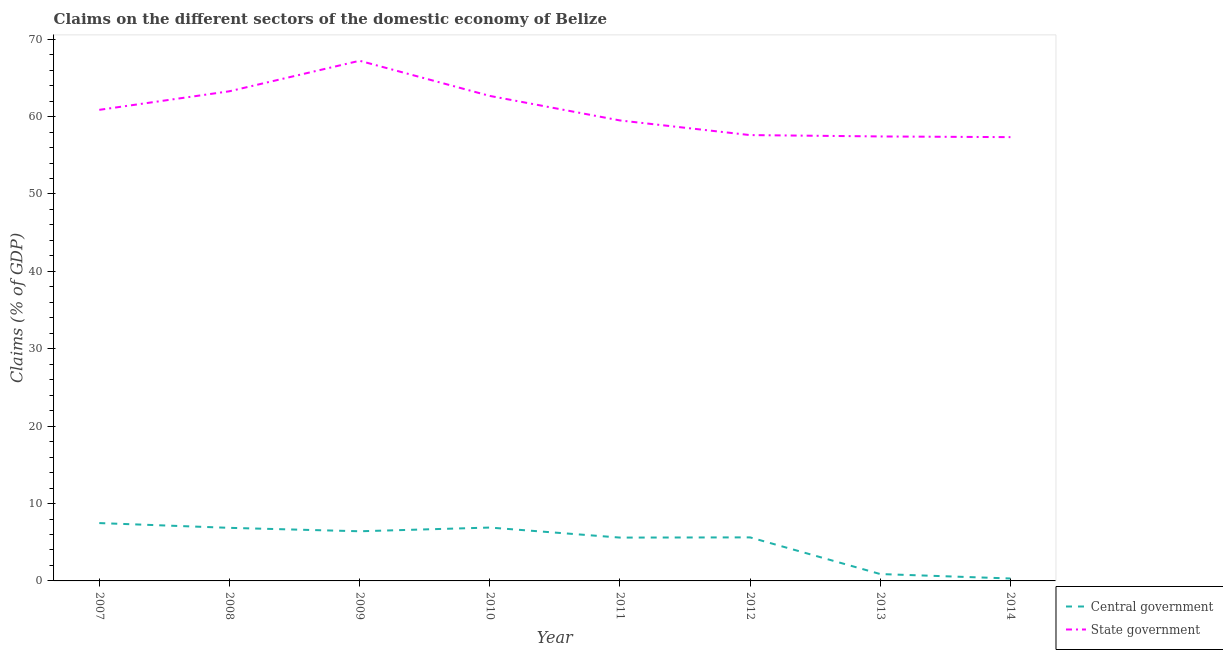How many different coloured lines are there?
Offer a terse response. 2. What is the claims on state government in 2007?
Your answer should be very brief. 60.87. Across all years, what is the maximum claims on central government?
Provide a short and direct response. 7.47. Across all years, what is the minimum claims on state government?
Keep it short and to the point. 57.35. In which year was the claims on state government maximum?
Ensure brevity in your answer.  2009. What is the total claims on state government in the graph?
Make the answer very short. 485.93. What is the difference between the claims on central government in 2008 and that in 2010?
Ensure brevity in your answer.  -0.04. What is the difference between the claims on central government in 2011 and the claims on state government in 2013?
Your answer should be very brief. -51.84. What is the average claims on central government per year?
Your response must be concise. 5.01. In the year 2011, what is the difference between the claims on state government and claims on central government?
Offer a very short reply. 53.9. What is the ratio of the claims on state government in 2011 to that in 2013?
Your answer should be compact. 1.04. Is the claims on central government in 2009 less than that in 2014?
Offer a very short reply. No. Is the difference between the claims on central government in 2007 and 2012 greater than the difference between the claims on state government in 2007 and 2012?
Keep it short and to the point. No. What is the difference between the highest and the second highest claims on state government?
Your answer should be very brief. 3.94. What is the difference between the highest and the lowest claims on state government?
Offer a very short reply. 9.87. In how many years, is the claims on state government greater than the average claims on state government taken over all years?
Provide a succinct answer. 4. How many lines are there?
Offer a very short reply. 2. How many years are there in the graph?
Offer a terse response. 8. Are the values on the major ticks of Y-axis written in scientific E-notation?
Your response must be concise. No. Does the graph contain any zero values?
Give a very brief answer. No. Where does the legend appear in the graph?
Ensure brevity in your answer.  Bottom right. What is the title of the graph?
Your response must be concise. Claims on the different sectors of the domestic economy of Belize. Does "Forest" appear as one of the legend labels in the graph?
Your response must be concise. No. What is the label or title of the X-axis?
Offer a terse response. Year. What is the label or title of the Y-axis?
Your answer should be very brief. Claims (% of GDP). What is the Claims (% of GDP) of Central government in 2007?
Provide a short and direct response. 7.47. What is the Claims (% of GDP) of State government in 2007?
Your response must be concise. 60.87. What is the Claims (% of GDP) of Central government in 2008?
Provide a short and direct response. 6.86. What is the Claims (% of GDP) in State government in 2008?
Make the answer very short. 63.27. What is the Claims (% of GDP) of Central government in 2009?
Offer a terse response. 6.42. What is the Claims (% of GDP) in State government in 2009?
Provide a short and direct response. 67.22. What is the Claims (% of GDP) in Central government in 2010?
Your response must be concise. 6.9. What is the Claims (% of GDP) of State government in 2010?
Offer a terse response. 62.67. What is the Claims (% of GDP) in Central government in 2011?
Your answer should be very brief. 5.6. What is the Claims (% of GDP) of State government in 2011?
Ensure brevity in your answer.  59.5. What is the Claims (% of GDP) in Central government in 2012?
Provide a succinct answer. 5.63. What is the Claims (% of GDP) of State government in 2012?
Give a very brief answer. 57.61. What is the Claims (% of GDP) in Central government in 2013?
Give a very brief answer. 0.89. What is the Claims (% of GDP) of State government in 2013?
Provide a succinct answer. 57.44. What is the Claims (% of GDP) in Central government in 2014?
Your response must be concise. 0.32. What is the Claims (% of GDP) in State government in 2014?
Provide a short and direct response. 57.35. Across all years, what is the maximum Claims (% of GDP) of Central government?
Your answer should be compact. 7.47. Across all years, what is the maximum Claims (% of GDP) of State government?
Give a very brief answer. 67.22. Across all years, what is the minimum Claims (% of GDP) of Central government?
Your answer should be compact. 0.32. Across all years, what is the minimum Claims (% of GDP) of State government?
Offer a terse response. 57.35. What is the total Claims (% of GDP) of Central government in the graph?
Your answer should be very brief. 40.07. What is the total Claims (% of GDP) in State government in the graph?
Make the answer very short. 485.93. What is the difference between the Claims (% of GDP) of Central government in 2007 and that in 2008?
Keep it short and to the point. 0.62. What is the difference between the Claims (% of GDP) of State government in 2007 and that in 2008?
Ensure brevity in your answer.  -2.4. What is the difference between the Claims (% of GDP) in Central government in 2007 and that in 2009?
Your response must be concise. 1.06. What is the difference between the Claims (% of GDP) in State government in 2007 and that in 2009?
Provide a succinct answer. -6.34. What is the difference between the Claims (% of GDP) of Central government in 2007 and that in 2010?
Offer a terse response. 0.58. What is the difference between the Claims (% of GDP) in State government in 2007 and that in 2010?
Your response must be concise. -1.8. What is the difference between the Claims (% of GDP) of Central government in 2007 and that in 2011?
Provide a short and direct response. 1.88. What is the difference between the Claims (% of GDP) in State government in 2007 and that in 2011?
Offer a very short reply. 1.37. What is the difference between the Claims (% of GDP) in Central government in 2007 and that in 2012?
Give a very brief answer. 1.85. What is the difference between the Claims (% of GDP) of State government in 2007 and that in 2012?
Keep it short and to the point. 3.26. What is the difference between the Claims (% of GDP) in Central government in 2007 and that in 2013?
Your response must be concise. 6.59. What is the difference between the Claims (% of GDP) of State government in 2007 and that in 2013?
Ensure brevity in your answer.  3.44. What is the difference between the Claims (% of GDP) of Central government in 2007 and that in 2014?
Your answer should be compact. 7.16. What is the difference between the Claims (% of GDP) of State government in 2007 and that in 2014?
Provide a short and direct response. 3.53. What is the difference between the Claims (% of GDP) in Central government in 2008 and that in 2009?
Offer a very short reply. 0.44. What is the difference between the Claims (% of GDP) of State government in 2008 and that in 2009?
Your answer should be very brief. -3.94. What is the difference between the Claims (% of GDP) of Central government in 2008 and that in 2010?
Make the answer very short. -0.04. What is the difference between the Claims (% of GDP) in State government in 2008 and that in 2010?
Your answer should be very brief. 0.6. What is the difference between the Claims (% of GDP) of Central government in 2008 and that in 2011?
Your answer should be very brief. 1.26. What is the difference between the Claims (% of GDP) of State government in 2008 and that in 2011?
Provide a short and direct response. 3.77. What is the difference between the Claims (% of GDP) in Central government in 2008 and that in 2012?
Keep it short and to the point. 1.23. What is the difference between the Claims (% of GDP) in State government in 2008 and that in 2012?
Offer a terse response. 5.66. What is the difference between the Claims (% of GDP) in Central government in 2008 and that in 2013?
Offer a terse response. 5.97. What is the difference between the Claims (% of GDP) of State government in 2008 and that in 2013?
Your response must be concise. 5.84. What is the difference between the Claims (% of GDP) in Central government in 2008 and that in 2014?
Keep it short and to the point. 6.54. What is the difference between the Claims (% of GDP) in State government in 2008 and that in 2014?
Your response must be concise. 5.93. What is the difference between the Claims (% of GDP) in Central government in 2009 and that in 2010?
Ensure brevity in your answer.  -0.48. What is the difference between the Claims (% of GDP) of State government in 2009 and that in 2010?
Provide a succinct answer. 4.54. What is the difference between the Claims (% of GDP) in Central government in 2009 and that in 2011?
Give a very brief answer. 0.82. What is the difference between the Claims (% of GDP) in State government in 2009 and that in 2011?
Provide a succinct answer. 7.71. What is the difference between the Claims (% of GDP) of Central government in 2009 and that in 2012?
Provide a succinct answer. 0.79. What is the difference between the Claims (% of GDP) of State government in 2009 and that in 2012?
Offer a very short reply. 9.6. What is the difference between the Claims (% of GDP) in Central government in 2009 and that in 2013?
Ensure brevity in your answer.  5.53. What is the difference between the Claims (% of GDP) in State government in 2009 and that in 2013?
Offer a terse response. 9.78. What is the difference between the Claims (% of GDP) in Central government in 2009 and that in 2014?
Give a very brief answer. 6.1. What is the difference between the Claims (% of GDP) in State government in 2009 and that in 2014?
Provide a short and direct response. 9.87. What is the difference between the Claims (% of GDP) of Central government in 2010 and that in 2011?
Make the answer very short. 1.3. What is the difference between the Claims (% of GDP) in State government in 2010 and that in 2011?
Your answer should be very brief. 3.17. What is the difference between the Claims (% of GDP) in Central government in 2010 and that in 2012?
Give a very brief answer. 1.27. What is the difference between the Claims (% of GDP) of State government in 2010 and that in 2012?
Your answer should be very brief. 5.06. What is the difference between the Claims (% of GDP) of Central government in 2010 and that in 2013?
Your answer should be compact. 6.01. What is the difference between the Claims (% of GDP) of State government in 2010 and that in 2013?
Your response must be concise. 5.24. What is the difference between the Claims (% of GDP) of Central government in 2010 and that in 2014?
Your response must be concise. 6.58. What is the difference between the Claims (% of GDP) of State government in 2010 and that in 2014?
Make the answer very short. 5.33. What is the difference between the Claims (% of GDP) of Central government in 2011 and that in 2012?
Provide a succinct answer. -0.03. What is the difference between the Claims (% of GDP) of State government in 2011 and that in 2012?
Make the answer very short. 1.89. What is the difference between the Claims (% of GDP) of Central government in 2011 and that in 2013?
Your response must be concise. 4.71. What is the difference between the Claims (% of GDP) in State government in 2011 and that in 2013?
Ensure brevity in your answer.  2.07. What is the difference between the Claims (% of GDP) of Central government in 2011 and that in 2014?
Your answer should be compact. 5.28. What is the difference between the Claims (% of GDP) of State government in 2011 and that in 2014?
Ensure brevity in your answer.  2.16. What is the difference between the Claims (% of GDP) in Central government in 2012 and that in 2013?
Make the answer very short. 4.74. What is the difference between the Claims (% of GDP) in State government in 2012 and that in 2013?
Provide a short and direct response. 0.18. What is the difference between the Claims (% of GDP) in Central government in 2012 and that in 2014?
Your answer should be very brief. 5.31. What is the difference between the Claims (% of GDP) of State government in 2012 and that in 2014?
Offer a very short reply. 0.27. What is the difference between the Claims (% of GDP) in Central government in 2013 and that in 2014?
Make the answer very short. 0.57. What is the difference between the Claims (% of GDP) in State government in 2013 and that in 2014?
Provide a short and direct response. 0.09. What is the difference between the Claims (% of GDP) of Central government in 2007 and the Claims (% of GDP) of State government in 2008?
Offer a very short reply. -55.8. What is the difference between the Claims (% of GDP) of Central government in 2007 and the Claims (% of GDP) of State government in 2009?
Give a very brief answer. -59.74. What is the difference between the Claims (% of GDP) of Central government in 2007 and the Claims (% of GDP) of State government in 2010?
Make the answer very short. -55.2. What is the difference between the Claims (% of GDP) of Central government in 2007 and the Claims (% of GDP) of State government in 2011?
Your response must be concise. -52.03. What is the difference between the Claims (% of GDP) in Central government in 2007 and the Claims (% of GDP) in State government in 2012?
Keep it short and to the point. -50.14. What is the difference between the Claims (% of GDP) of Central government in 2007 and the Claims (% of GDP) of State government in 2013?
Your answer should be compact. -49.96. What is the difference between the Claims (% of GDP) in Central government in 2007 and the Claims (% of GDP) in State government in 2014?
Provide a short and direct response. -49.87. What is the difference between the Claims (% of GDP) of Central government in 2008 and the Claims (% of GDP) of State government in 2009?
Your answer should be very brief. -60.36. What is the difference between the Claims (% of GDP) in Central government in 2008 and the Claims (% of GDP) in State government in 2010?
Offer a terse response. -55.82. What is the difference between the Claims (% of GDP) of Central government in 2008 and the Claims (% of GDP) of State government in 2011?
Make the answer very short. -52.65. What is the difference between the Claims (% of GDP) in Central government in 2008 and the Claims (% of GDP) in State government in 2012?
Your answer should be very brief. -50.75. What is the difference between the Claims (% of GDP) in Central government in 2008 and the Claims (% of GDP) in State government in 2013?
Ensure brevity in your answer.  -50.58. What is the difference between the Claims (% of GDP) in Central government in 2008 and the Claims (% of GDP) in State government in 2014?
Give a very brief answer. -50.49. What is the difference between the Claims (% of GDP) of Central government in 2009 and the Claims (% of GDP) of State government in 2010?
Give a very brief answer. -56.26. What is the difference between the Claims (% of GDP) of Central government in 2009 and the Claims (% of GDP) of State government in 2011?
Make the answer very short. -53.09. What is the difference between the Claims (% of GDP) in Central government in 2009 and the Claims (% of GDP) in State government in 2012?
Ensure brevity in your answer.  -51.2. What is the difference between the Claims (% of GDP) of Central government in 2009 and the Claims (% of GDP) of State government in 2013?
Offer a very short reply. -51.02. What is the difference between the Claims (% of GDP) of Central government in 2009 and the Claims (% of GDP) of State government in 2014?
Keep it short and to the point. -50.93. What is the difference between the Claims (% of GDP) of Central government in 2010 and the Claims (% of GDP) of State government in 2011?
Keep it short and to the point. -52.61. What is the difference between the Claims (% of GDP) of Central government in 2010 and the Claims (% of GDP) of State government in 2012?
Your answer should be very brief. -50.72. What is the difference between the Claims (% of GDP) of Central government in 2010 and the Claims (% of GDP) of State government in 2013?
Keep it short and to the point. -50.54. What is the difference between the Claims (% of GDP) of Central government in 2010 and the Claims (% of GDP) of State government in 2014?
Give a very brief answer. -50.45. What is the difference between the Claims (% of GDP) of Central government in 2011 and the Claims (% of GDP) of State government in 2012?
Provide a succinct answer. -52.01. What is the difference between the Claims (% of GDP) of Central government in 2011 and the Claims (% of GDP) of State government in 2013?
Your answer should be compact. -51.84. What is the difference between the Claims (% of GDP) of Central government in 2011 and the Claims (% of GDP) of State government in 2014?
Offer a very short reply. -51.75. What is the difference between the Claims (% of GDP) in Central government in 2012 and the Claims (% of GDP) in State government in 2013?
Your answer should be very brief. -51.81. What is the difference between the Claims (% of GDP) in Central government in 2012 and the Claims (% of GDP) in State government in 2014?
Your response must be concise. -51.72. What is the difference between the Claims (% of GDP) in Central government in 2013 and the Claims (% of GDP) in State government in 2014?
Keep it short and to the point. -56.46. What is the average Claims (% of GDP) of Central government per year?
Your answer should be compact. 5.01. What is the average Claims (% of GDP) of State government per year?
Provide a short and direct response. 60.74. In the year 2007, what is the difference between the Claims (% of GDP) in Central government and Claims (% of GDP) in State government?
Your answer should be compact. -53.4. In the year 2008, what is the difference between the Claims (% of GDP) in Central government and Claims (% of GDP) in State government?
Offer a very short reply. -56.42. In the year 2009, what is the difference between the Claims (% of GDP) in Central government and Claims (% of GDP) in State government?
Your answer should be very brief. -60.8. In the year 2010, what is the difference between the Claims (% of GDP) in Central government and Claims (% of GDP) in State government?
Keep it short and to the point. -55.78. In the year 2011, what is the difference between the Claims (% of GDP) of Central government and Claims (% of GDP) of State government?
Ensure brevity in your answer.  -53.9. In the year 2012, what is the difference between the Claims (% of GDP) of Central government and Claims (% of GDP) of State government?
Ensure brevity in your answer.  -51.99. In the year 2013, what is the difference between the Claims (% of GDP) of Central government and Claims (% of GDP) of State government?
Keep it short and to the point. -56.55. In the year 2014, what is the difference between the Claims (% of GDP) in Central government and Claims (% of GDP) in State government?
Provide a succinct answer. -57.03. What is the ratio of the Claims (% of GDP) of Central government in 2007 to that in 2008?
Your answer should be very brief. 1.09. What is the ratio of the Claims (% of GDP) in State government in 2007 to that in 2008?
Provide a succinct answer. 0.96. What is the ratio of the Claims (% of GDP) in Central government in 2007 to that in 2009?
Give a very brief answer. 1.17. What is the ratio of the Claims (% of GDP) in State government in 2007 to that in 2009?
Your answer should be very brief. 0.91. What is the ratio of the Claims (% of GDP) in Central government in 2007 to that in 2010?
Provide a succinct answer. 1.08. What is the ratio of the Claims (% of GDP) of State government in 2007 to that in 2010?
Ensure brevity in your answer.  0.97. What is the ratio of the Claims (% of GDP) in Central government in 2007 to that in 2011?
Your response must be concise. 1.33. What is the ratio of the Claims (% of GDP) of Central government in 2007 to that in 2012?
Provide a succinct answer. 1.33. What is the ratio of the Claims (% of GDP) in State government in 2007 to that in 2012?
Provide a short and direct response. 1.06. What is the ratio of the Claims (% of GDP) in Central government in 2007 to that in 2013?
Offer a terse response. 8.42. What is the ratio of the Claims (% of GDP) in State government in 2007 to that in 2013?
Make the answer very short. 1.06. What is the ratio of the Claims (% of GDP) in Central government in 2007 to that in 2014?
Your answer should be very brief. 23.72. What is the ratio of the Claims (% of GDP) of State government in 2007 to that in 2014?
Provide a succinct answer. 1.06. What is the ratio of the Claims (% of GDP) in Central government in 2008 to that in 2009?
Offer a very short reply. 1.07. What is the ratio of the Claims (% of GDP) in State government in 2008 to that in 2009?
Make the answer very short. 0.94. What is the ratio of the Claims (% of GDP) in Central government in 2008 to that in 2010?
Keep it short and to the point. 0.99. What is the ratio of the Claims (% of GDP) in State government in 2008 to that in 2010?
Your answer should be compact. 1.01. What is the ratio of the Claims (% of GDP) in Central government in 2008 to that in 2011?
Your answer should be compact. 1.22. What is the ratio of the Claims (% of GDP) of State government in 2008 to that in 2011?
Make the answer very short. 1.06. What is the ratio of the Claims (% of GDP) in Central government in 2008 to that in 2012?
Provide a succinct answer. 1.22. What is the ratio of the Claims (% of GDP) of State government in 2008 to that in 2012?
Give a very brief answer. 1.1. What is the ratio of the Claims (% of GDP) of Central government in 2008 to that in 2013?
Your answer should be compact. 7.72. What is the ratio of the Claims (% of GDP) of State government in 2008 to that in 2013?
Make the answer very short. 1.1. What is the ratio of the Claims (% of GDP) of Central government in 2008 to that in 2014?
Make the answer very short. 21.76. What is the ratio of the Claims (% of GDP) of State government in 2008 to that in 2014?
Your answer should be compact. 1.1. What is the ratio of the Claims (% of GDP) of Central government in 2009 to that in 2010?
Your answer should be very brief. 0.93. What is the ratio of the Claims (% of GDP) of State government in 2009 to that in 2010?
Provide a succinct answer. 1.07. What is the ratio of the Claims (% of GDP) of Central government in 2009 to that in 2011?
Offer a terse response. 1.15. What is the ratio of the Claims (% of GDP) in State government in 2009 to that in 2011?
Your answer should be very brief. 1.13. What is the ratio of the Claims (% of GDP) in Central government in 2009 to that in 2012?
Your response must be concise. 1.14. What is the ratio of the Claims (% of GDP) of State government in 2009 to that in 2012?
Your answer should be compact. 1.17. What is the ratio of the Claims (% of GDP) of Central government in 2009 to that in 2013?
Offer a terse response. 7.23. What is the ratio of the Claims (% of GDP) in State government in 2009 to that in 2013?
Offer a terse response. 1.17. What is the ratio of the Claims (% of GDP) of Central government in 2009 to that in 2014?
Offer a terse response. 20.36. What is the ratio of the Claims (% of GDP) in State government in 2009 to that in 2014?
Your answer should be compact. 1.17. What is the ratio of the Claims (% of GDP) in Central government in 2010 to that in 2011?
Offer a terse response. 1.23. What is the ratio of the Claims (% of GDP) of State government in 2010 to that in 2011?
Make the answer very short. 1.05. What is the ratio of the Claims (% of GDP) of Central government in 2010 to that in 2012?
Your response must be concise. 1.23. What is the ratio of the Claims (% of GDP) of State government in 2010 to that in 2012?
Your response must be concise. 1.09. What is the ratio of the Claims (% of GDP) of Central government in 2010 to that in 2013?
Offer a terse response. 7.77. What is the ratio of the Claims (% of GDP) of State government in 2010 to that in 2013?
Your response must be concise. 1.09. What is the ratio of the Claims (% of GDP) of Central government in 2010 to that in 2014?
Offer a terse response. 21.88. What is the ratio of the Claims (% of GDP) in State government in 2010 to that in 2014?
Your response must be concise. 1.09. What is the ratio of the Claims (% of GDP) of State government in 2011 to that in 2012?
Keep it short and to the point. 1.03. What is the ratio of the Claims (% of GDP) of Central government in 2011 to that in 2013?
Your response must be concise. 6.31. What is the ratio of the Claims (% of GDP) of State government in 2011 to that in 2013?
Give a very brief answer. 1.04. What is the ratio of the Claims (% of GDP) in Central government in 2011 to that in 2014?
Your answer should be very brief. 17.77. What is the ratio of the Claims (% of GDP) in State government in 2011 to that in 2014?
Provide a short and direct response. 1.04. What is the ratio of the Claims (% of GDP) of Central government in 2012 to that in 2013?
Your response must be concise. 6.34. What is the ratio of the Claims (% of GDP) in Central government in 2012 to that in 2014?
Give a very brief answer. 17.85. What is the ratio of the Claims (% of GDP) of State government in 2012 to that in 2014?
Offer a very short reply. 1. What is the ratio of the Claims (% of GDP) in Central government in 2013 to that in 2014?
Your answer should be very brief. 2.82. What is the difference between the highest and the second highest Claims (% of GDP) in Central government?
Give a very brief answer. 0.58. What is the difference between the highest and the second highest Claims (% of GDP) in State government?
Keep it short and to the point. 3.94. What is the difference between the highest and the lowest Claims (% of GDP) of Central government?
Make the answer very short. 7.16. What is the difference between the highest and the lowest Claims (% of GDP) in State government?
Provide a succinct answer. 9.87. 